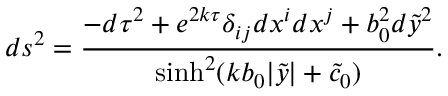Convert formula to latex. <formula><loc_0><loc_0><loc_500><loc_500>d s ^ { 2 } = \frac { - d \tau ^ { 2 } + e ^ { 2 k \tau } \delta _ { i j } d x ^ { i } d x ^ { j } + b _ { 0 } ^ { 2 } d { \tilde { y } } ^ { 2 } } { \sinh ^ { 2 } ( k b _ { 0 } | \tilde { y } | + \tilde { c } _ { 0 } ) } .</formula> 